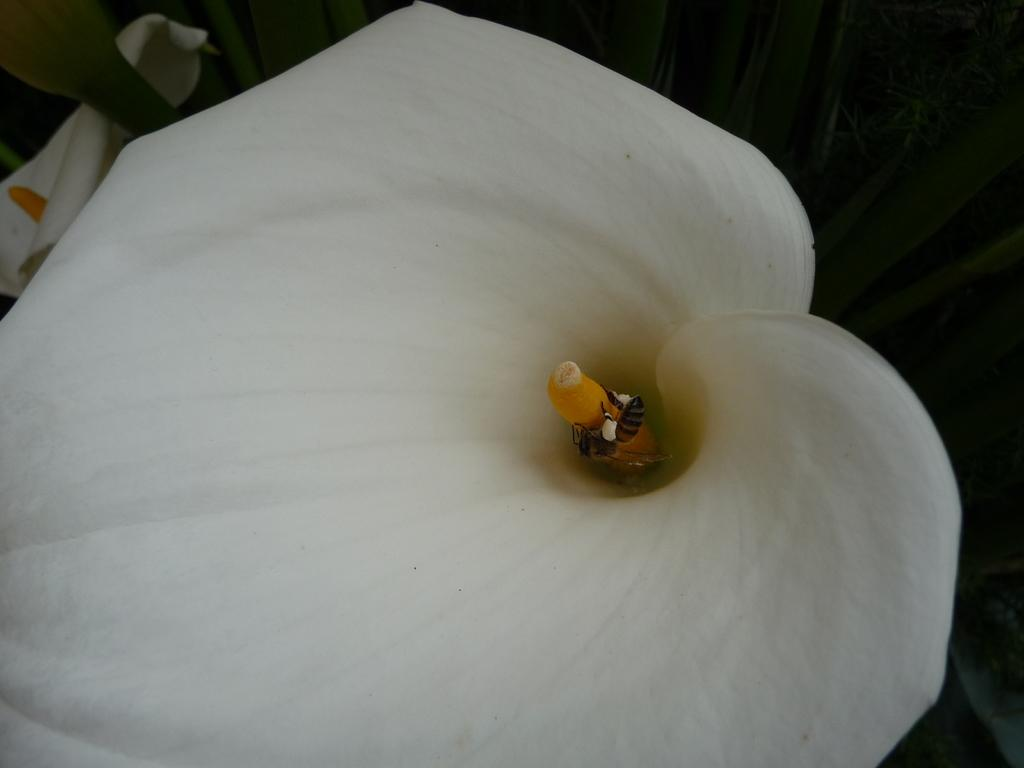What color are the flowers in the image? The flowers in the image are white in color. How many white flowers can be seen in the image? There are two white flowers in the image. What is the color of the background in the image? The background of the image is black in color. What way do the flowers create harmony in the image? The flowers themselves do not create harmony in the image, as harmony is a concept related to the arrangement or combination of elements. However, the contrast between the white flowers and the black background might create a visually pleasing effect. 